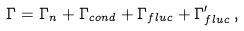Convert formula to latex. <formula><loc_0><loc_0><loc_500><loc_500>\Gamma = \Gamma _ { n } + { \Gamma } _ { c o n d } + { \Gamma } _ { f l u c } + \Gamma _ { f l u c } ^ { \prime } \, ,</formula> 